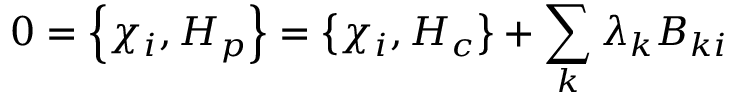Convert formula to latex. <formula><loc_0><loc_0><loc_500><loc_500>0 = \left \{ \chi _ { i } , H _ { p } \right \} = \left \{ \chi _ { i } , H _ { c } \right \} + \sum _ { k } \lambda _ { k } B _ { k i }</formula> 